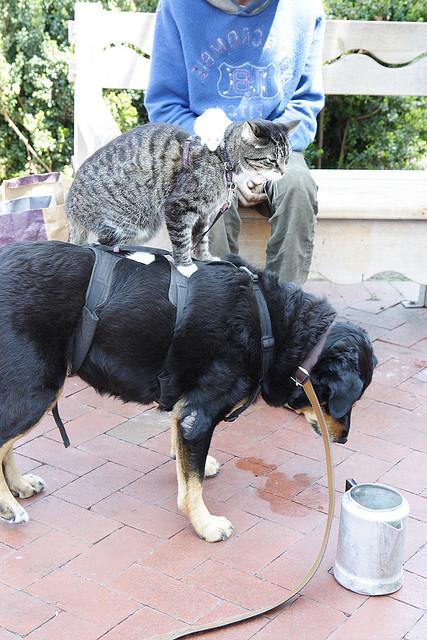What type of dog is shown?
Quick response, please. Rottweiler. How many animals are there?
Quick response, please. 2. What is on the dog's back?
Concise answer only. Cat. 